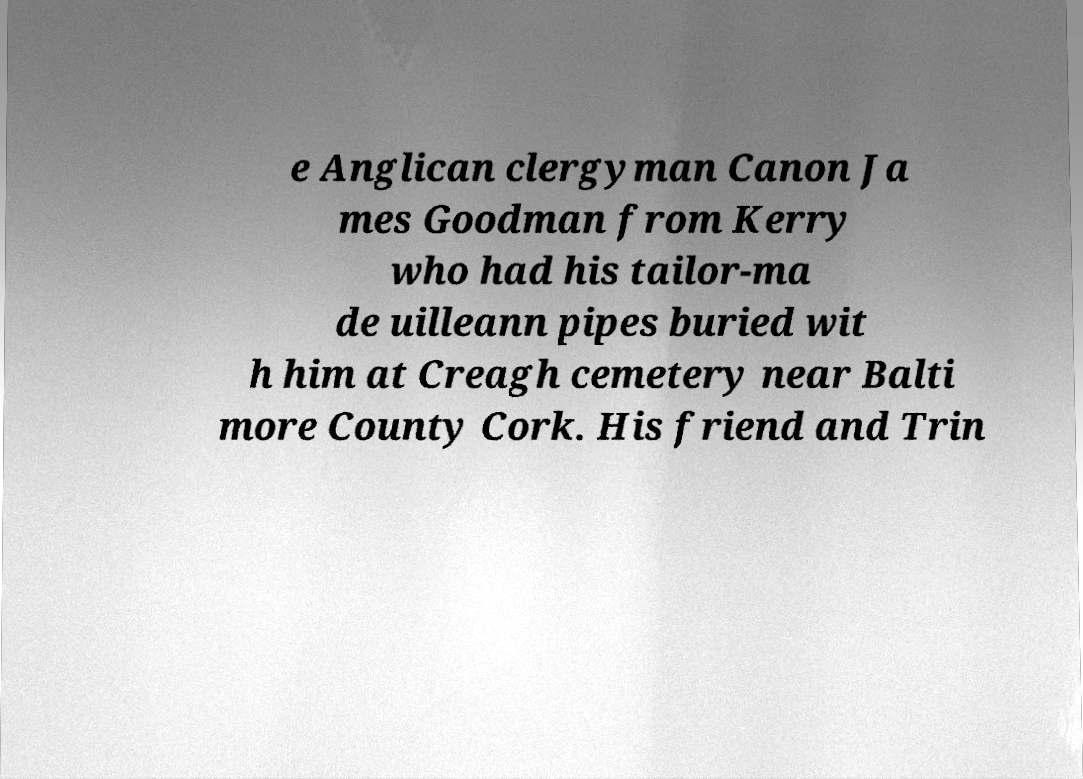Please read and relay the text visible in this image. What does it say? e Anglican clergyman Canon Ja mes Goodman from Kerry who had his tailor-ma de uilleann pipes buried wit h him at Creagh cemetery near Balti more County Cork. His friend and Trin 